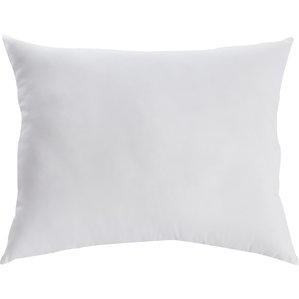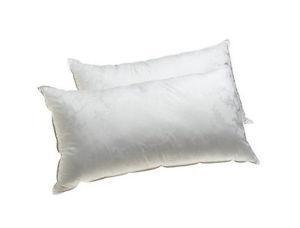The first image is the image on the left, the second image is the image on the right. Assess this claim about the two images: "An image contains exactly three white pillows, and an image shows multiple pillows on a bed with a white blanket.". Correct or not? Answer yes or no. No. The first image is the image on the left, the second image is the image on the right. Assess this claim about the two images: "There are at most 3 pillows in the pair of images.". Correct or not? Answer yes or no. Yes. 